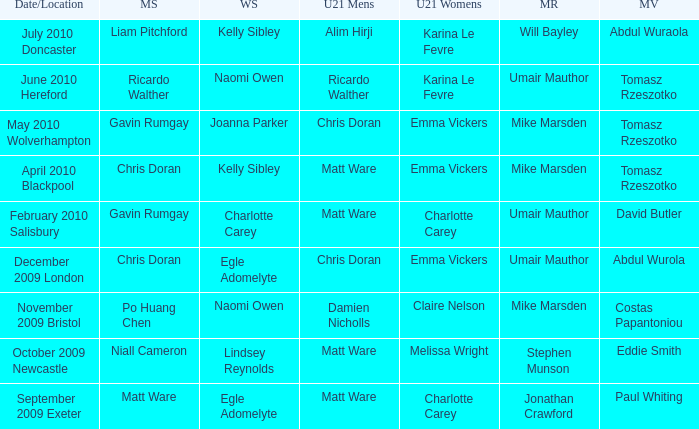When and where did Eddie Smith win the mixed veteran? 1.0. 